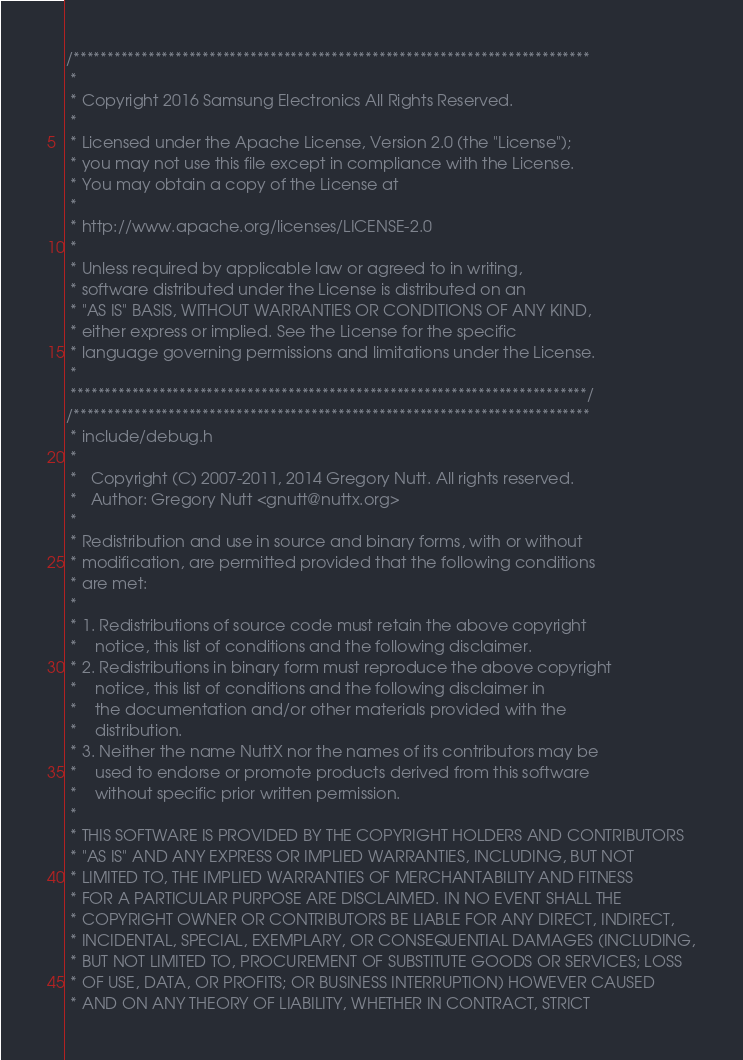Convert code to text. <code><loc_0><loc_0><loc_500><loc_500><_C_>/****************************************************************************
 *
 * Copyright 2016 Samsung Electronics All Rights Reserved.
 *
 * Licensed under the Apache License, Version 2.0 (the "License");
 * you may not use this file except in compliance with the License.
 * You may obtain a copy of the License at
 *
 * http://www.apache.org/licenses/LICENSE-2.0
 *
 * Unless required by applicable law or agreed to in writing,
 * software distributed under the License is distributed on an
 * "AS IS" BASIS, WITHOUT WARRANTIES OR CONDITIONS OF ANY KIND,
 * either express or implied. See the License for the specific
 * language governing permissions and limitations under the License.
 *
 ****************************************************************************/
/****************************************************************************
 * include/debug.h
 *
 *   Copyright (C) 2007-2011, 2014 Gregory Nutt. All rights reserved.
 *   Author: Gregory Nutt <gnutt@nuttx.org>
 *
 * Redistribution and use in source and binary forms, with or without
 * modification, are permitted provided that the following conditions
 * are met:
 *
 * 1. Redistributions of source code must retain the above copyright
 *    notice, this list of conditions and the following disclaimer.
 * 2. Redistributions in binary form must reproduce the above copyright
 *    notice, this list of conditions and the following disclaimer in
 *    the documentation and/or other materials provided with the
 *    distribution.
 * 3. Neither the name NuttX nor the names of its contributors may be
 *    used to endorse or promote products derived from this software
 *    without specific prior written permission.
 *
 * THIS SOFTWARE IS PROVIDED BY THE COPYRIGHT HOLDERS AND CONTRIBUTORS
 * "AS IS" AND ANY EXPRESS OR IMPLIED WARRANTIES, INCLUDING, BUT NOT
 * LIMITED TO, THE IMPLIED WARRANTIES OF MERCHANTABILITY AND FITNESS
 * FOR A PARTICULAR PURPOSE ARE DISCLAIMED. IN NO EVENT SHALL THE
 * COPYRIGHT OWNER OR CONTRIBUTORS BE LIABLE FOR ANY DIRECT, INDIRECT,
 * INCIDENTAL, SPECIAL, EXEMPLARY, OR CONSEQUENTIAL DAMAGES (INCLUDING,
 * BUT NOT LIMITED TO, PROCUREMENT OF SUBSTITUTE GOODS OR SERVICES; LOSS
 * OF USE, DATA, OR PROFITS; OR BUSINESS INTERRUPTION) HOWEVER CAUSED
 * AND ON ANY THEORY OF LIABILITY, WHETHER IN CONTRACT, STRICT</code> 